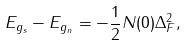Convert formula to latex. <formula><loc_0><loc_0><loc_500><loc_500>E _ { g _ { s } } - E _ { g _ { n } } = - \frac { 1 } { 2 } N ( 0 ) \Delta _ { F } ^ { 2 } ,</formula> 